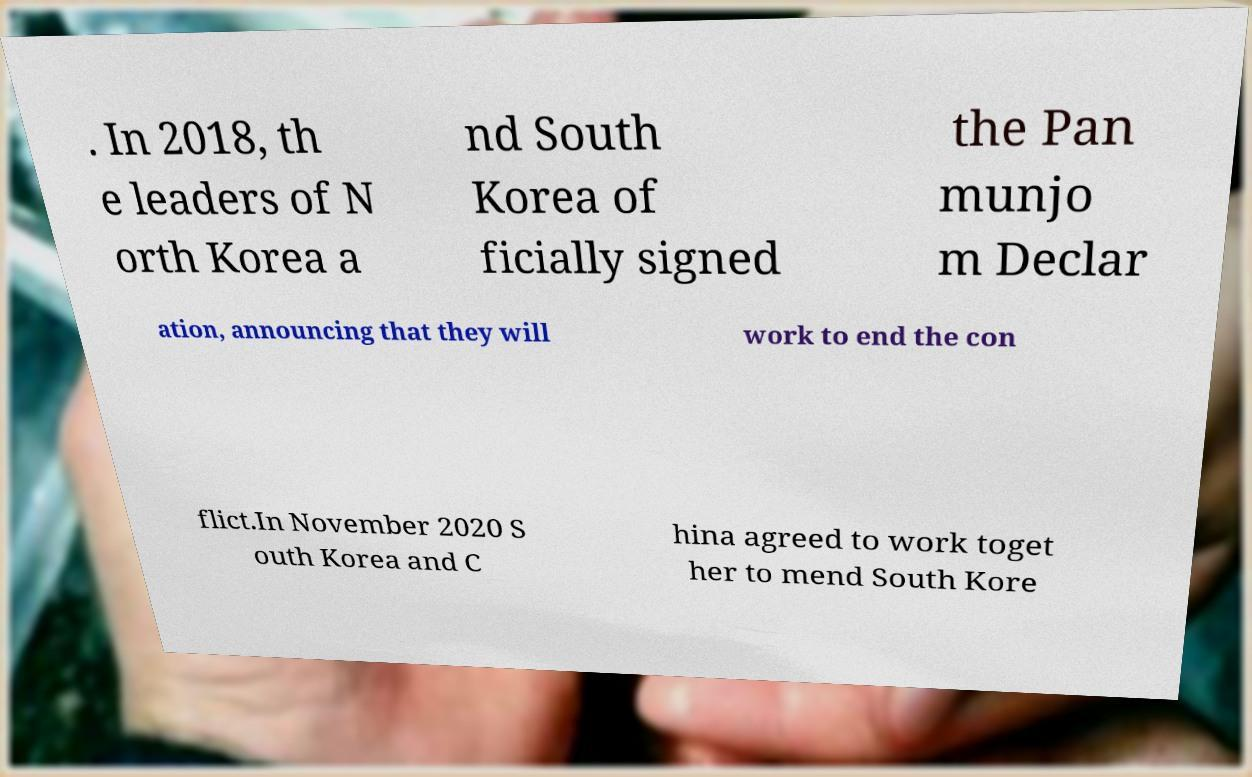Can you accurately transcribe the text from the provided image for me? . In 2018, th e leaders of N orth Korea a nd South Korea of ficially signed the Pan munjo m Declar ation, announcing that they will work to end the con flict.In November 2020 S outh Korea and C hina agreed to work toget her to mend South Kore 